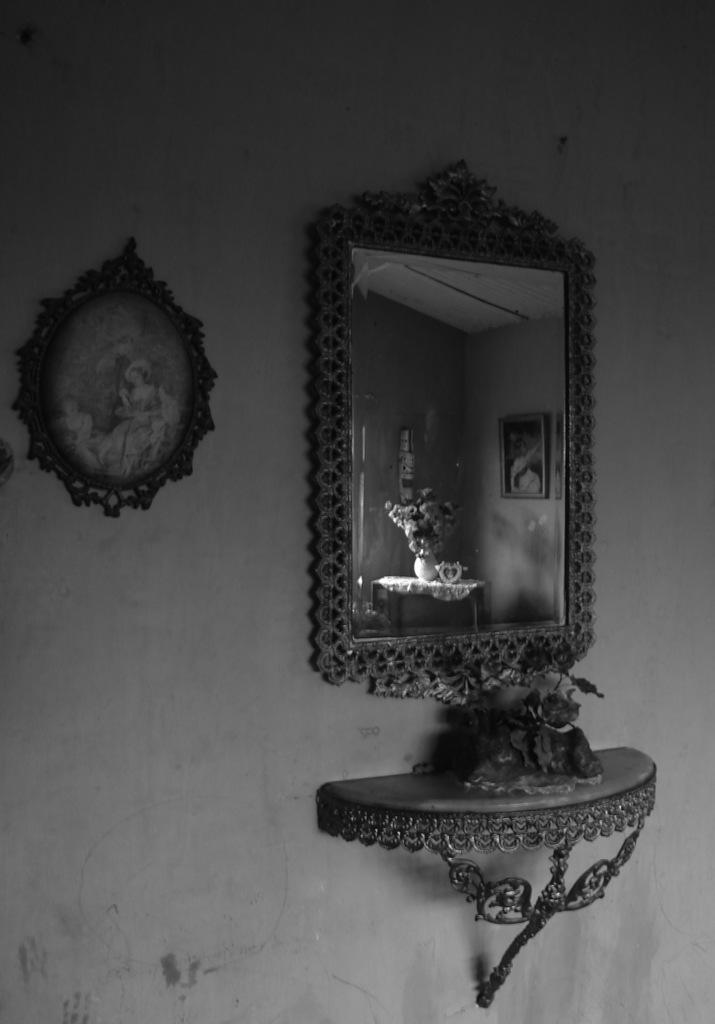What is the color scheme of the image? The image is black and white. What can be seen on the wall in the image? There is a mirror on the wall in the image. What else is present in the image besides the wall and mirror? There is a frame in the image. What type of chin can be seen in the image? There is no chin present in the image, as it is a black and white image featuring a wall, mirror, and frame. 